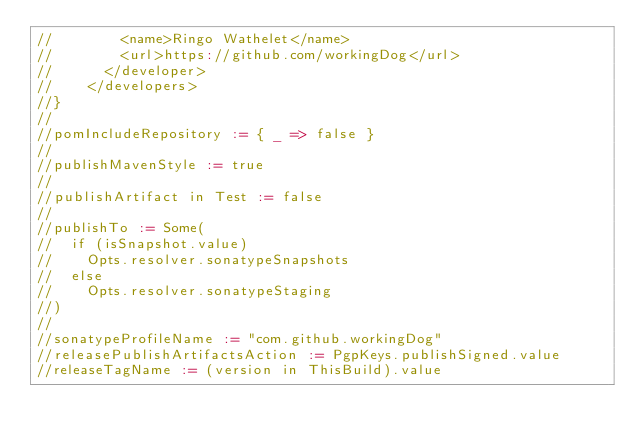Convert code to text. <code><loc_0><loc_0><loc_500><loc_500><_Scala_>//        <name>Ringo Wathelet</name>
//        <url>https://github.com/workingDog</url>
//      </developer>
//    </developers>
//}
//
//pomIncludeRepository := { _ => false }
//
//publishMavenStyle := true
//
//publishArtifact in Test := false
//
//publishTo := Some(
//  if (isSnapshot.value)
//    Opts.resolver.sonatypeSnapshots
//  else
//    Opts.resolver.sonatypeStaging
//)
//
//sonatypeProfileName := "com.github.workingDog"
//releasePublishArtifactsAction := PgpKeys.publishSigned.value
//releaseTagName := (version in ThisBuild).value

</code> 